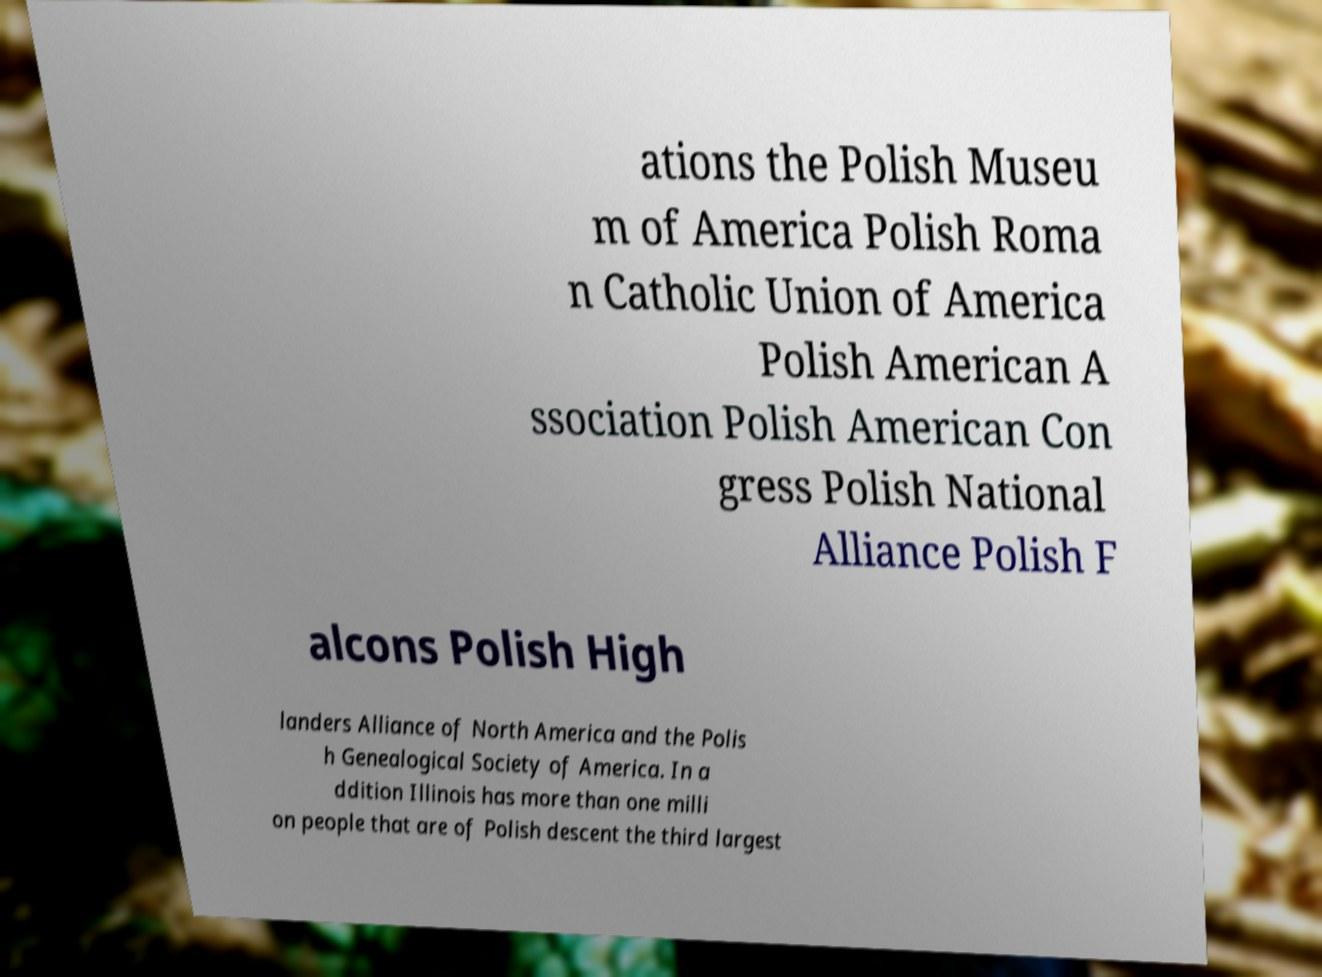What messages or text are displayed in this image? I need them in a readable, typed format. ations the Polish Museu m of America Polish Roma n Catholic Union of America Polish American A ssociation Polish American Con gress Polish National Alliance Polish F alcons Polish High landers Alliance of North America and the Polis h Genealogical Society of America. In a ddition Illinois has more than one milli on people that are of Polish descent the third largest 